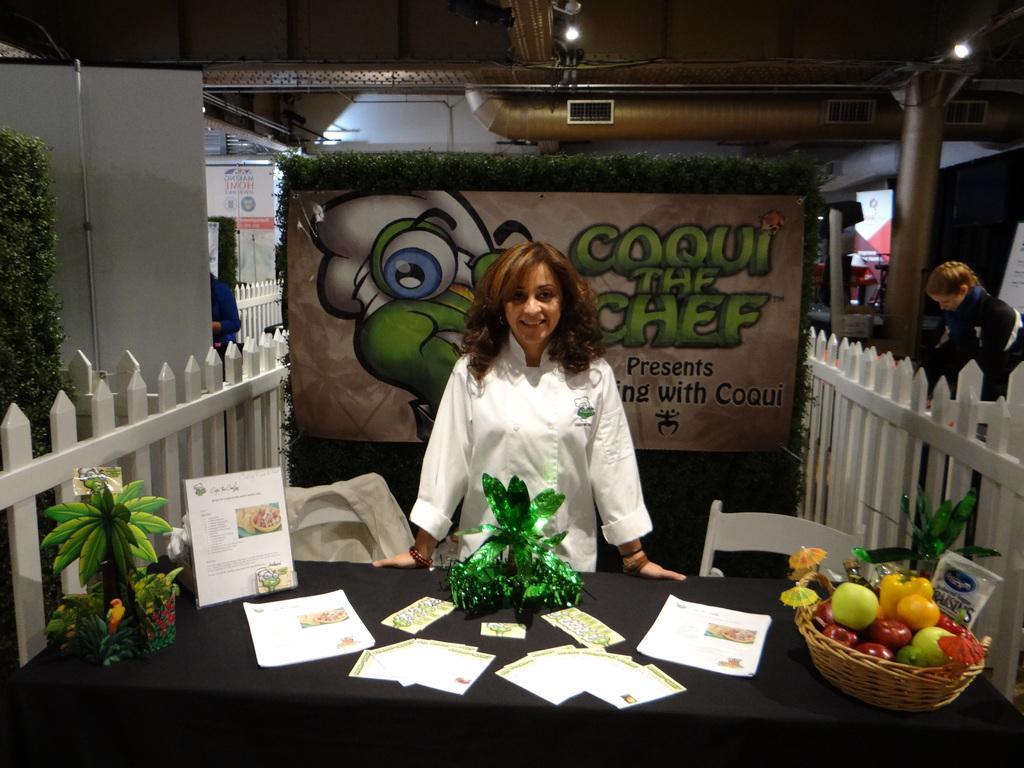In one or two sentences, can you explain what this image depicts? At the bottom of the image there is a table. On the table there are papers, basket with fruits and some other things on it. Behind the table there is a person standing and also there are chairs. On the left side of the image there is a wooden fencing. Behind the fencing there is a plant and also there is a board. On the right side of the image there is a fencing and behind the fencing there is a person. In the background there is a banner. At the top of the image there is ceiling with lights and pipes. And also there are pillars in the background. 